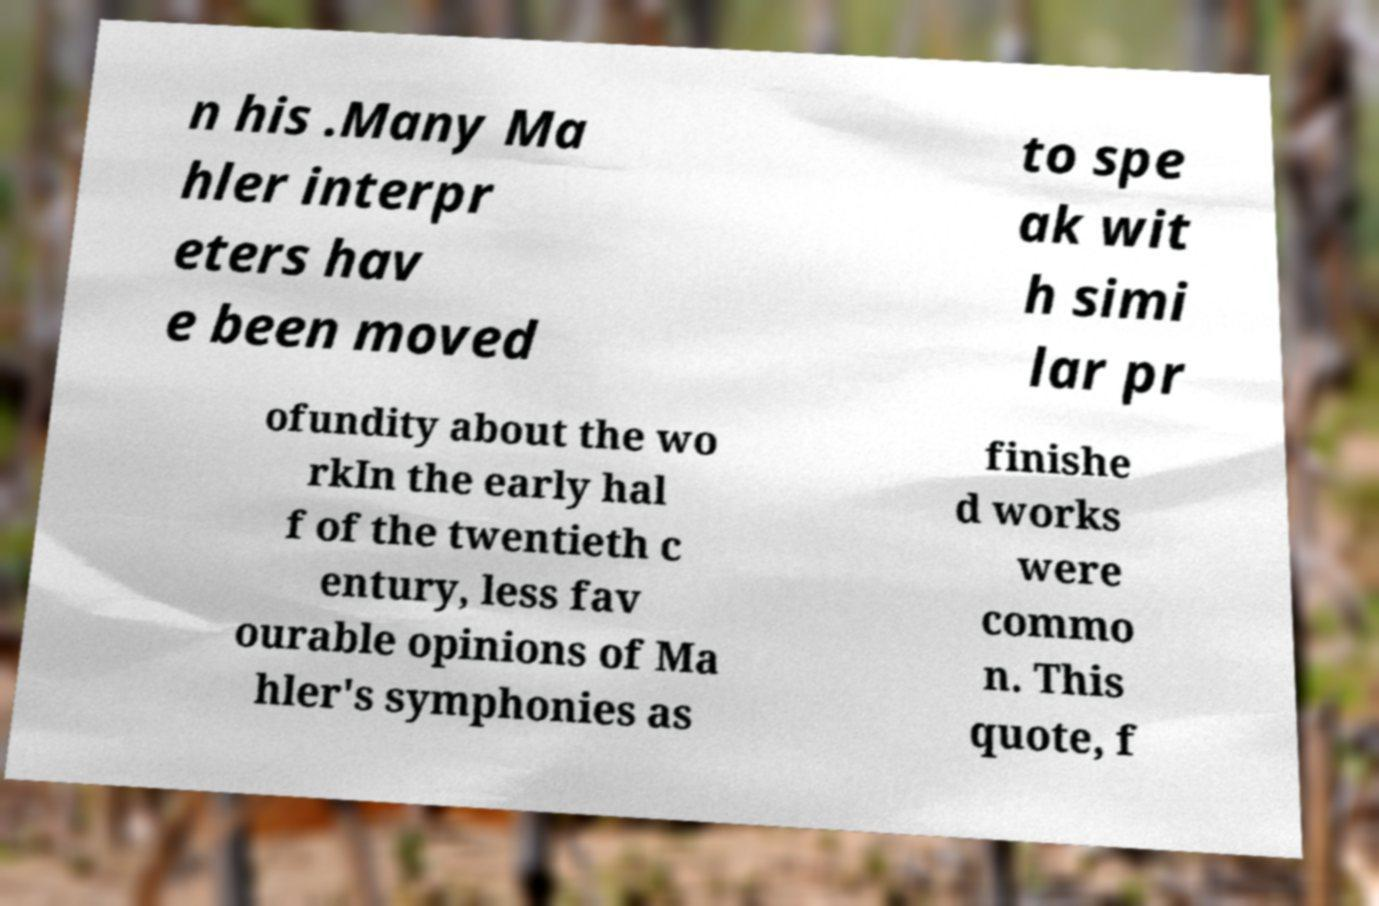Can you accurately transcribe the text from the provided image for me? n his .Many Ma hler interpr eters hav e been moved to spe ak wit h simi lar pr ofundity about the wo rkIn the early hal f of the twentieth c entury, less fav ourable opinions of Ma hler's symphonies as finishe d works were commo n. This quote, f 